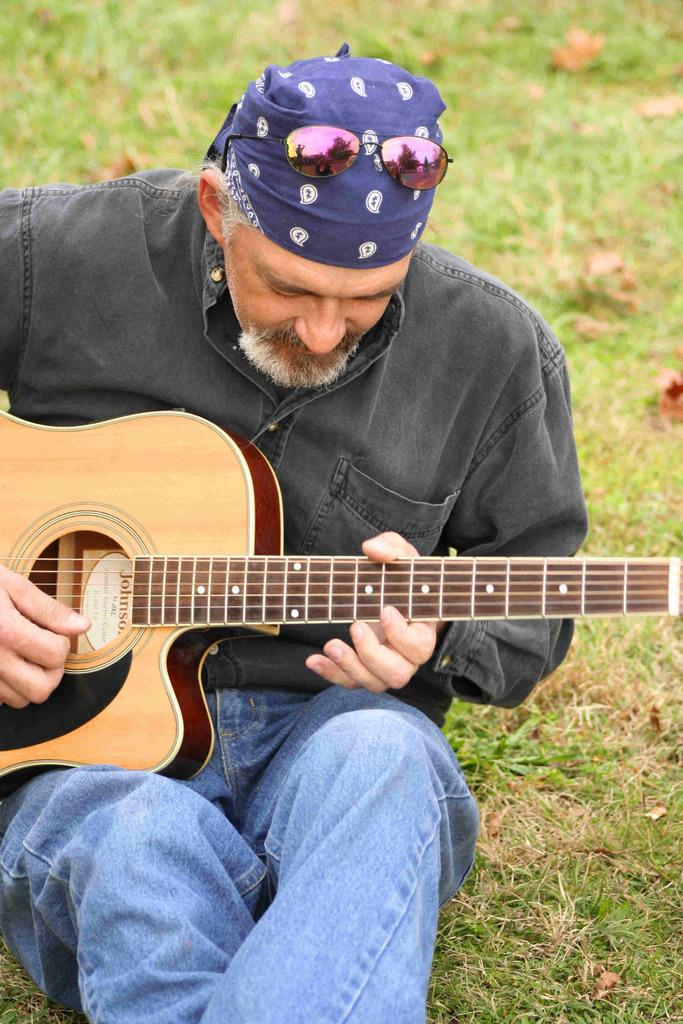Who is the person in the image? There is a man in the image. What is the man wearing on his head? The man is wearing goggles on his head. What is the man holding in the image? The man is holding a guitar. What is the man doing with the guitar? The man is playing the guitar. What can be seen in the background of the image? There is grass in the background of the image. What type of jar is the man using to play the guitar in the image? There is no jar present in the image, and the man is playing the guitar with his hands, not a jar. 